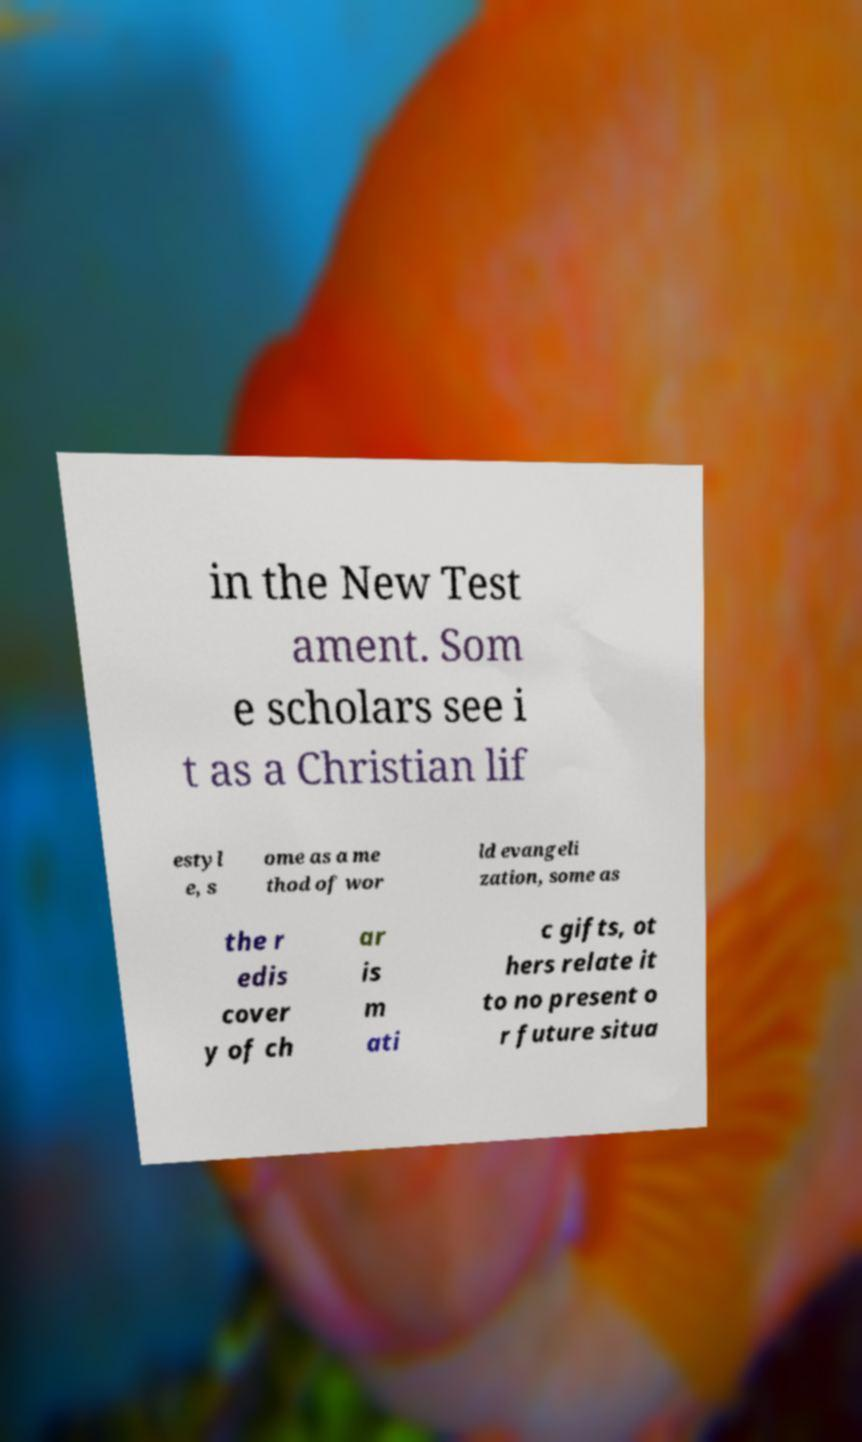Can you accurately transcribe the text from the provided image for me? in the New Test ament. Som e scholars see i t as a Christian lif estyl e, s ome as a me thod of wor ld evangeli zation, some as the r edis cover y of ch ar is m ati c gifts, ot hers relate it to no present o r future situa 